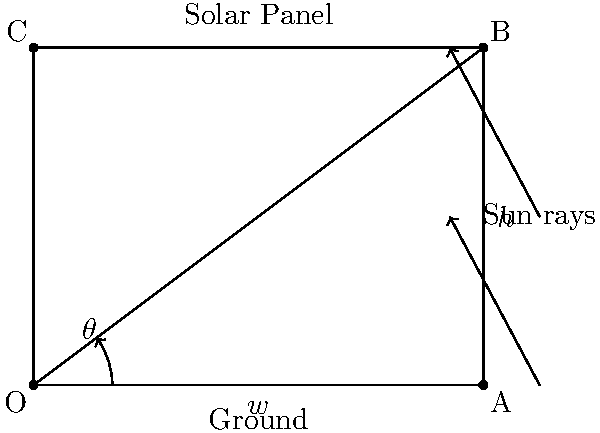As the head of the tech department, you're tasked with optimizing the energy capture of a new solar panel installation. The panel is mounted on a flat roof with a width of 4 meters and can be adjusted to any angle. If the panel's height (h) is 3 meters when fully vertical, at what angle $\theta$ (in degrees) should the panel be tilted to maximize energy capture, assuming the sun is directly overhead? To solve this problem, we'll follow these steps:

1) For maximum energy capture, the solar panel should be perpendicular to the sun's rays when the sun is directly overhead.

2) In this position, the panel forms a right triangle with the roof and a line perpendicular to the sun's rays.

3) We know the width of the roof (w = 4 meters) and the height of the panel (h = 3 meters).

4) In a right triangle, $\tan(\theta) = \frac{\text{opposite}}{\text{adjacent}} = \frac{h}{w}$

5) Substituting our values:
   $\tan(\theta) = \frac{3}{4}$

6) To find $\theta$, we need to use the inverse tangent (arctan or $\tan^{-1}$):
   $\theta = \tan^{-1}(\frac{3}{4})$

7) Using a calculator or trigonometric tables:
   $\theta \approx 36.87°$

8) Rounding to the nearest degree:
   $\theta \approx 37°$

This angle will position the solar panel perpendicular to the sun's rays when it's directly overhead, maximizing energy capture.
Answer: $37°$ 